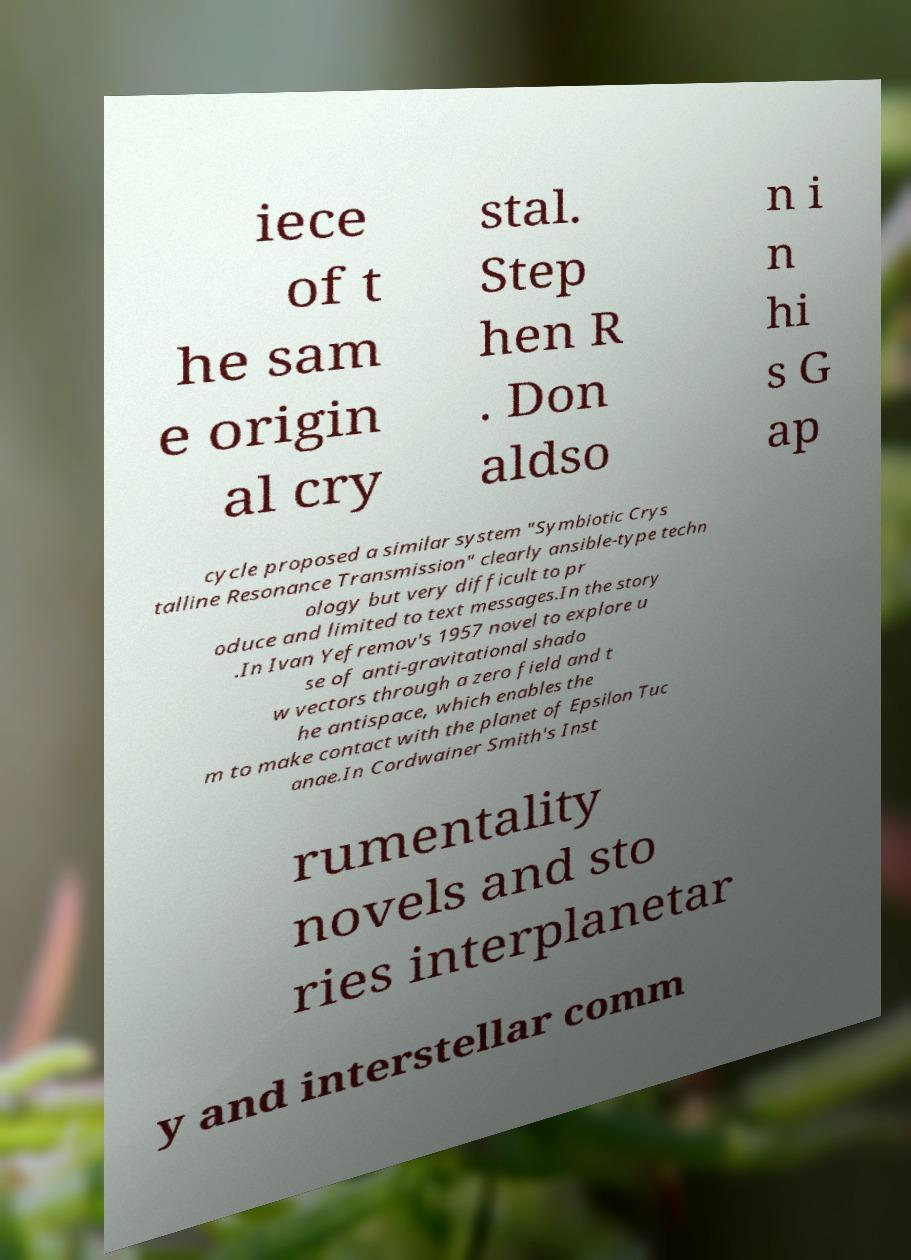Could you extract and type out the text from this image? iece of t he sam e origin al cry stal. Step hen R . Don aldso n i n hi s G ap cycle proposed a similar system "Symbiotic Crys talline Resonance Transmission" clearly ansible-type techn ology but very difficult to pr oduce and limited to text messages.In the story .In Ivan Yefremov's 1957 novel to explore u se of anti-gravitational shado w vectors through a zero field and t he antispace, which enables the m to make contact with the planet of Epsilon Tuc anae.In Cordwainer Smith's Inst rumentality novels and sto ries interplanetar y and interstellar comm 